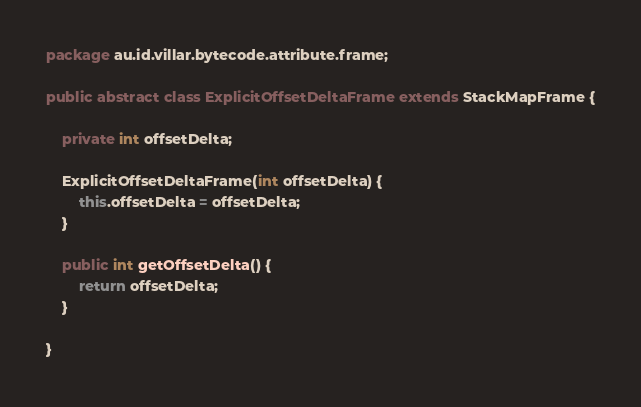Convert code to text. <code><loc_0><loc_0><loc_500><loc_500><_Java_>package au.id.villar.bytecode.attribute.frame;

public abstract class ExplicitOffsetDeltaFrame extends StackMapFrame {

	private int offsetDelta;

	ExplicitOffsetDeltaFrame(int offsetDelta) {
		this.offsetDelta = offsetDelta;
	}

	public int getOffsetDelta() {
		return offsetDelta;
	}

}
</code> 